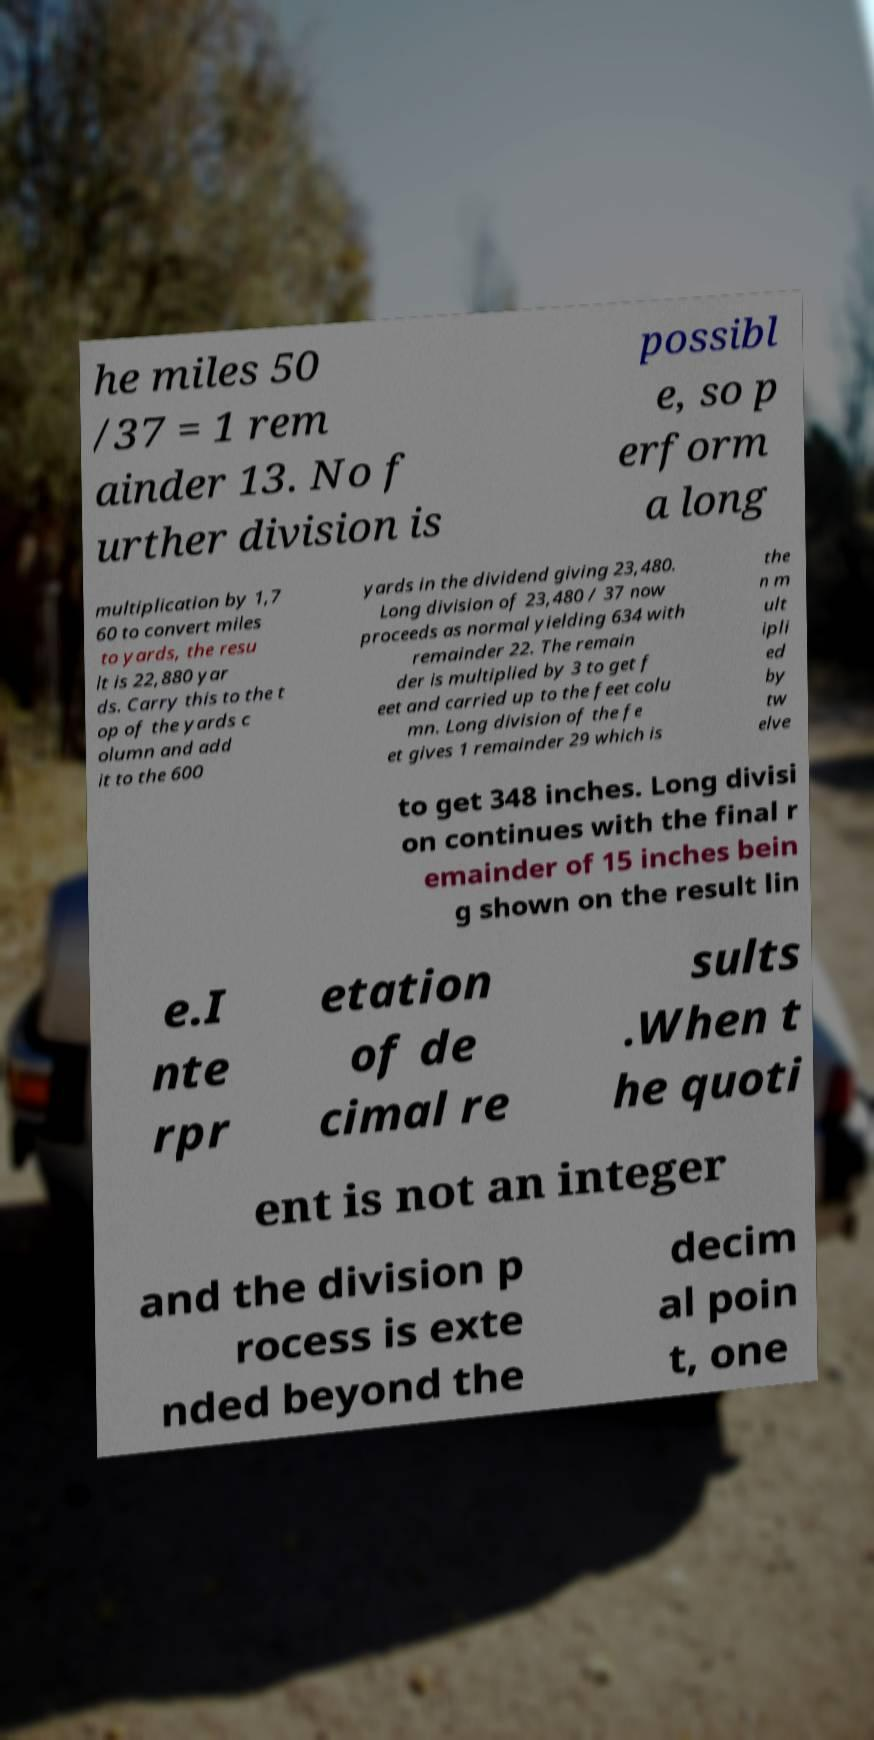There's text embedded in this image that I need extracted. Can you transcribe it verbatim? he miles 50 /37 = 1 rem ainder 13. No f urther division is possibl e, so p erform a long multiplication by 1,7 60 to convert miles to yards, the resu lt is 22,880 yar ds. Carry this to the t op of the yards c olumn and add it to the 600 yards in the dividend giving 23,480. Long division of 23,480 / 37 now proceeds as normal yielding 634 with remainder 22. The remain der is multiplied by 3 to get f eet and carried up to the feet colu mn. Long division of the fe et gives 1 remainder 29 which is the n m ult ipli ed by tw elve to get 348 inches. Long divisi on continues with the final r emainder of 15 inches bein g shown on the result lin e.I nte rpr etation of de cimal re sults .When t he quoti ent is not an integer and the division p rocess is exte nded beyond the decim al poin t, one 